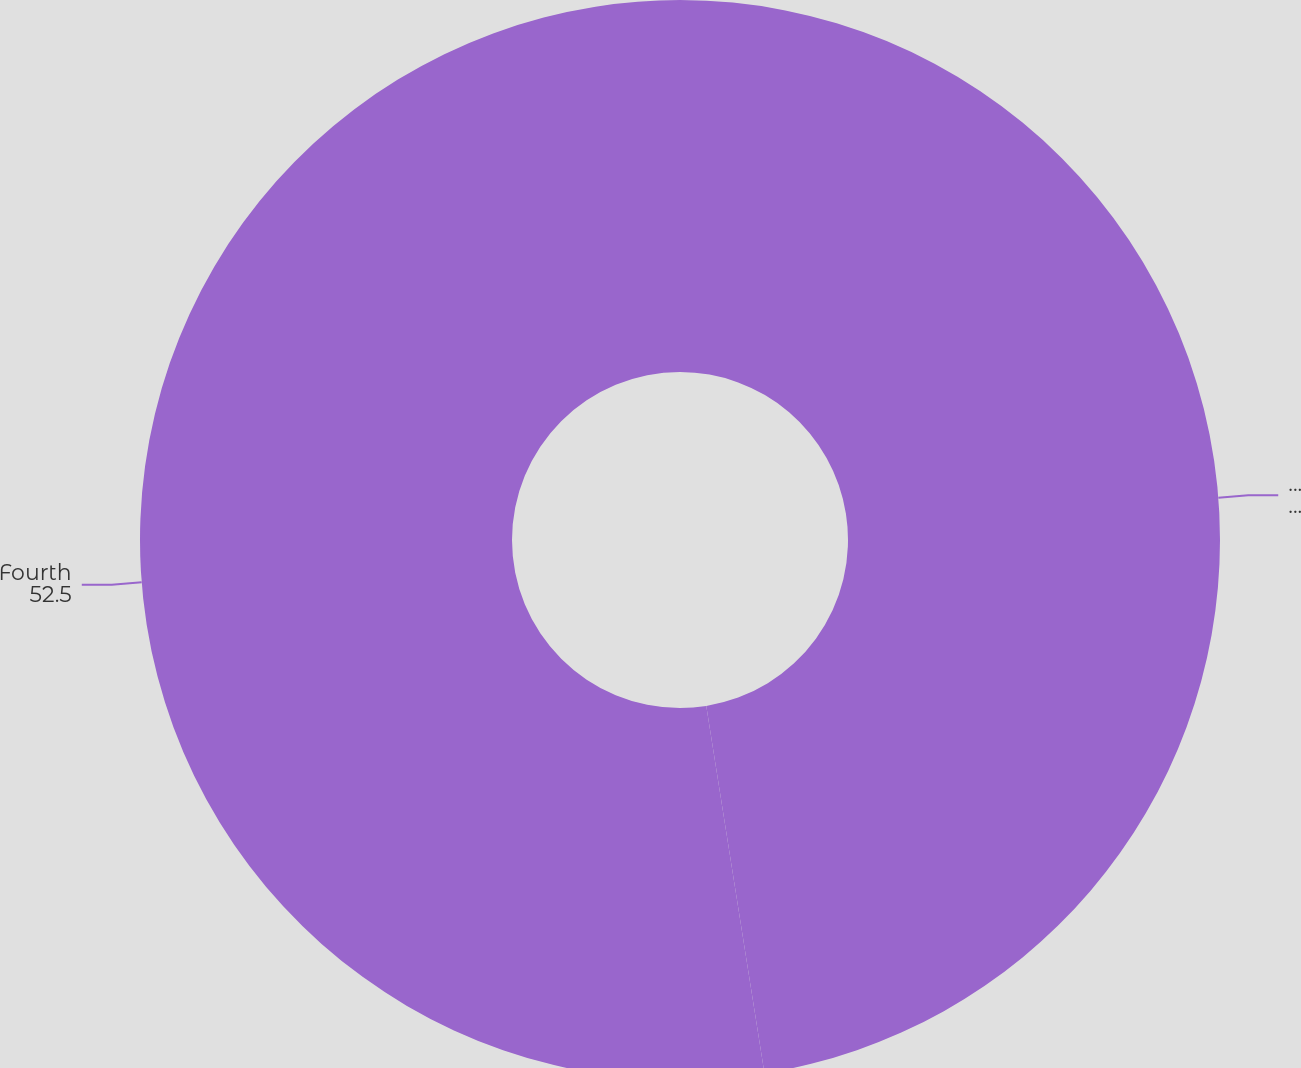Convert chart. <chart><loc_0><loc_0><loc_500><loc_500><pie_chart><fcel>First Second<fcel>Fourth<nl><fcel>47.5%<fcel>52.5%<nl></chart> 